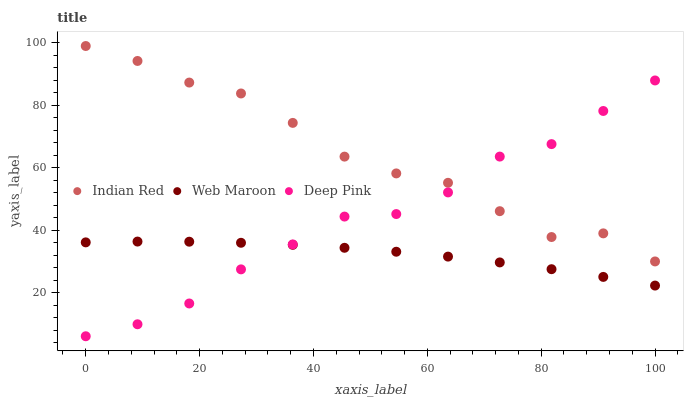Does Web Maroon have the minimum area under the curve?
Answer yes or no. Yes. Does Indian Red have the maximum area under the curve?
Answer yes or no. Yes. Does Indian Red have the minimum area under the curve?
Answer yes or no. No. Does Web Maroon have the maximum area under the curve?
Answer yes or no. No. Is Web Maroon the smoothest?
Answer yes or no. Yes. Is Indian Red the roughest?
Answer yes or no. Yes. Is Indian Red the smoothest?
Answer yes or no. No. Is Web Maroon the roughest?
Answer yes or no. No. Does Deep Pink have the lowest value?
Answer yes or no. Yes. Does Web Maroon have the lowest value?
Answer yes or no. No. Does Indian Red have the highest value?
Answer yes or no. Yes. Does Web Maroon have the highest value?
Answer yes or no. No. Is Web Maroon less than Indian Red?
Answer yes or no. Yes. Is Indian Red greater than Web Maroon?
Answer yes or no. Yes. Does Indian Red intersect Deep Pink?
Answer yes or no. Yes. Is Indian Red less than Deep Pink?
Answer yes or no. No. Is Indian Red greater than Deep Pink?
Answer yes or no. No. Does Web Maroon intersect Indian Red?
Answer yes or no. No. 